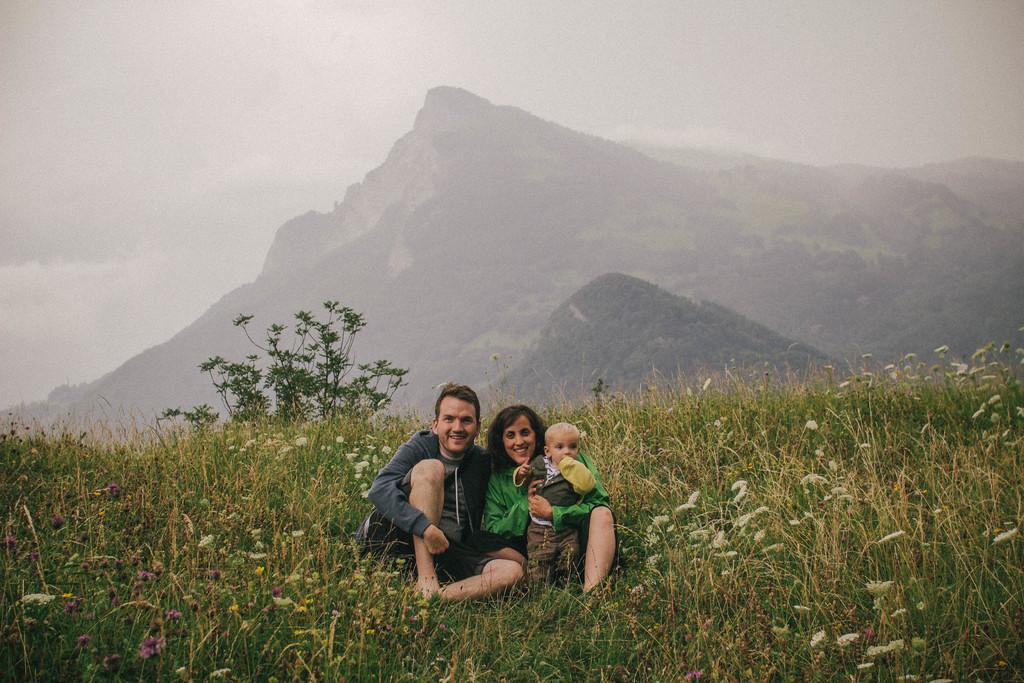Please provide a concise description of this image. There are people those who are sitting in the center of the image on the grassland, it seems to be there is greenery and sky in the background area. 